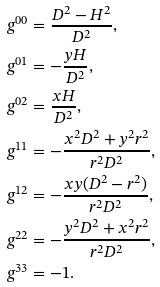<formula> <loc_0><loc_0><loc_500><loc_500>g ^ { 0 0 } & = \frac { D ^ { 2 } - H ^ { 2 } } { D ^ { 2 } } , \\ g ^ { 0 1 } & = - \frac { y H } { D ^ { 2 } } , \\ g ^ { 0 2 } & = \frac { x H } { D ^ { 2 } } , \\ g ^ { 1 1 } & = - \frac { x ^ { 2 } D ^ { 2 } + y ^ { 2 } r ^ { 2 } } { r ^ { 2 } D ^ { 2 } } , \\ g ^ { 1 2 } & = - \frac { x y ( D ^ { 2 } - r ^ { 2 } ) } { r ^ { 2 } D ^ { 2 } } , \\ g ^ { 2 2 } & = - \frac { y ^ { 2 } D ^ { 2 } + x ^ { 2 } r ^ { 2 } } { r ^ { 2 } D ^ { 2 } } , \\ g ^ { 3 3 } & = - 1 .</formula> 